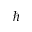<formula> <loc_0><loc_0><loc_500><loc_500>\hbar</formula> 